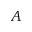Convert formula to latex. <formula><loc_0><loc_0><loc_500><loc_500>A</formula> 